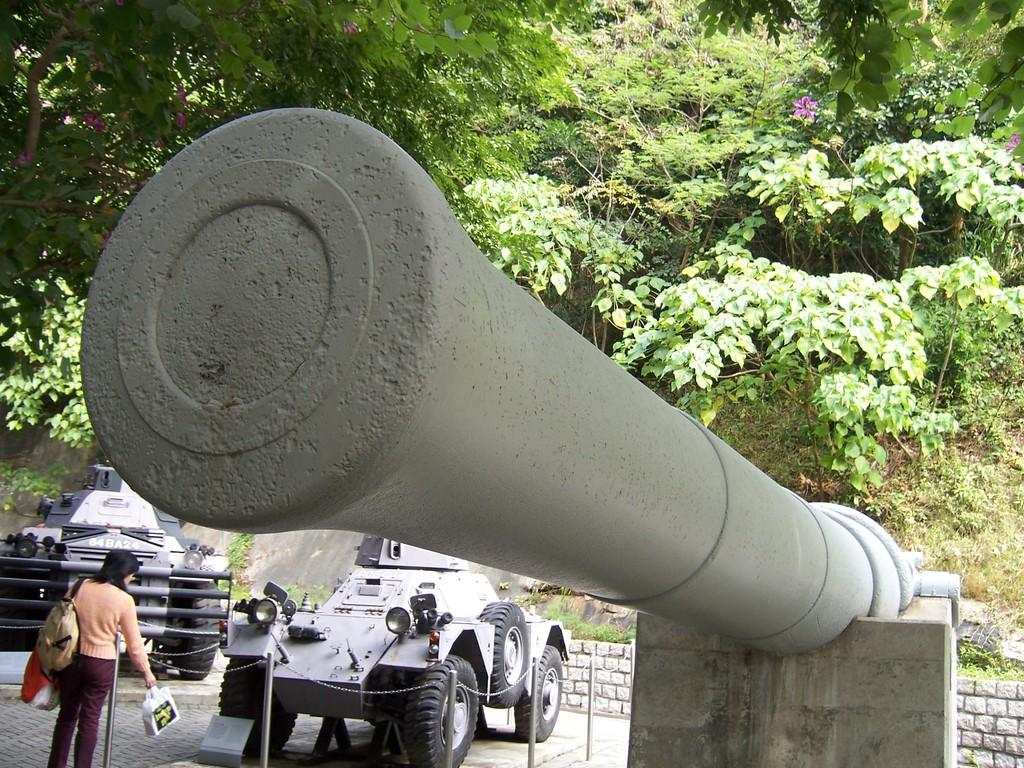What is the main object in the image? There is a cannon in the image. What else can be seen in the image besides the cannon? There are vehicles, a person carrying bags and standing on the ground, poles, and a wall in the image. What is visible in the background of the image? Trees are visible in the background of the image. What type of coast can be seen in the image? There is no coast present in the image; it features a cannon, vehicles, a person carrying bags, poles, a wall, and trees in the background. 